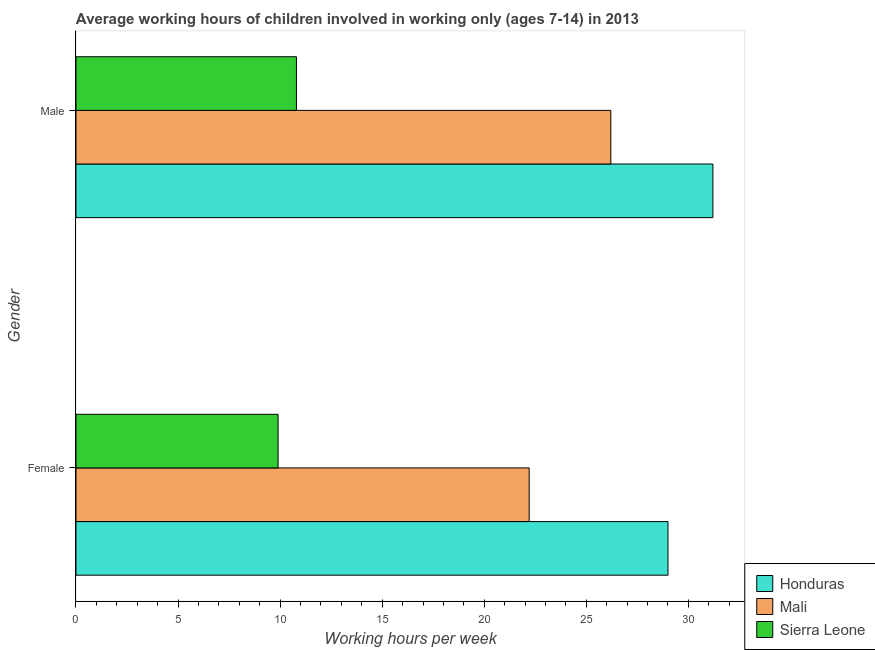How many different coloured bars are there?
Provide a succinct answer. 3. How many bars are there on the 1st tick from the bottom?
Provide a short and direct response. 3. What is the average working hour of male children in Sierra Leone?
Your answer should be very brief. 10.8. Across all countries, what is the maximum average working hour of male children?
Provide a succinct answer. 31.2. In which country was the average working hour of male children maximum?
Your answer should be very brief. Honduras. In which country was the average working hour of female children minimum?
Ensure brevity in your answer.  Sierra Leone. What is the total average working hour of male children in the graph?
Provide a short and direct response. 68.2. What is the difference between the average working hour of male children in Honduras and that in Sierra Leone?
Give a very brief answer. 20.4. What is the difference between the average working hour of female children in Mali and the average working hour of male children in Honduras?
Give a very brief answer. -9. What is the average average working hour of female children per country?
Your answer should be compact. 20.37. What is the difference between the average working hour of male children and average working hour of female children in Mali?
Ensure brevity in your answer.  4. In how many countries, is the average working hour of female children greater than 10 hours?
Your answer should be very brief. 2. What is the ratio of the average working hour of female children in Sierra Leone to that in Mali?
Your response must be concise. 0.45. Is the average working hour of male children in Mali less than that in Sierra Leone?
Offer a very short reply. No. What does the 3rd bar from the top in Female represents?
Ensure brevity in your answer.  Honduras. What does the 1st bar from the bottom in Male represents?
Offer a very short reply. Honduras. How many countries are there in the graph?
Provide a short and direct response. 3. What is the difference between two consecutive major ticks on the X-axis?
Your answer should be very brief. 5. Are the values on the major ticks of X-axis written in scientific E-notation?
Your answer should be compact. No. Does the graph contain any zero values?
Keep it short and to the point. No. How many legend labels are there?
Your answer should be very brief. 3. What is the title of the graph?
Offer a terse response. Average working hours of children involved in working only (ages 7-14) in 2013. Does "Latin America(developing only)" appear as one of the legend labels in the graph?
Your answer should be very brief. No. What is the label or title of the X-axis?
Provide a short and direct response. Working hours per week. What is the label or title of the Y-axis?
Your answer should be compact. Gender. What is the Working hours per week of Honduras in Female?
Your answer should be very brief. 29. What is the Working hours per week of Mali in Female?
Offer a terse response. 22.2. What is the Working hours per week of Honduras in Male?
Your answer should be very brief. 31.2. What is the Working hours per week of Mali in Male?
Provide a short and direct response. 26.2. What is the Working hours per week of Sierra Leone in Male?
Keep it short and to the point. 10.8. Across all Gender, what is the maximum Working hours per week of Honduras?
Provide a short and direct response. 31.2. Across all Gender, what is the maximum Working hours per week of Mali?
Your answer should be compact. 26.2. Across all Gender, what is the maximum Working hours per week of Sierra Leone?
Provide a short and direct response. 10.8. Across all Gender, what is the minimum Working hours per week of Honduras?
Give a very brief answer. 29. Across all Gender, what is the minimum Working hours per week in Sierra Leone?
Your response must be concise. 9.9. What is the total Working hours per week in Honduras in the graph?
Keep it short and to the point. 60.2. What is the total Working hours per week in Mali in the graph?
Offer a terse response. 48.4. What is the total Working hours per week in Sierra Leone in the graph?
Make the answer very short. 20.7. What is the difference between the Working hours per week in Honduras in Female and that in Male?
Your response must be concise. -2.2. What is the difference between the Working hours per week of Mali in Female and that in Male?
Provide a succinct answer. -4. What is the difference between the Working hours per week in Sierra Leone in Female and that in Male?
Your response must be concise. -0.9. What is the difference between the Working hours per week of Mali in Female and the Working hours per week of Sierra Leone in Male?
Keep it short and to the point. 11.4. What is the average Working hours per week of Honduras per Gender?
Make the answer very short. 30.1. What is the average Working hours per week in Mali per Gender?
Provide a succinct answer. 24.2. What is the average Working hours per week of Sierra Leone per Gender?
Offer a very short reply. 10.35. What is the difference between the Working hours per week of Honduras and Working hours per week of Sierra Leone in Female?
Offer a terse response. 19.1. What is the difference between the Working hours per week of Honduras and Working hours per week of Mali in Male?
Keep it short and to the point. 5. What is the difference between the Working hours per week of Honduras and Working hours per week of Sierra Leone in Male?
Keep it short and to the point. 20.4. What is the difference between the Working hours per week in Mali and Working hours per week in Sierra Leone in Male?
Ensure brevity in your answer.  15.4. What is the ratio of the Working hours per week in Honduras in Female to that in Male?
Your response must be concise. 0.93. What is the ratio of the Working hours per week of Mali in Female to that in Male?
Keep it short and to the point. 0.85. What is the ratio of the Working hours per week of Sierra Leone in Female to that in Male?
Keep it short and to the point. 0.92. What is the difference between the highest and the second highest Working hours per week of Mali?
Provide a succinct answer. 4. What is the difference between the highest and the lowest Working hours per week in Mali?
Provide a short and direct response. 4. 